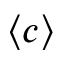<formula> <loc_0><loc_0><loc_500><loc_500>\langle c \rangle</formula> 